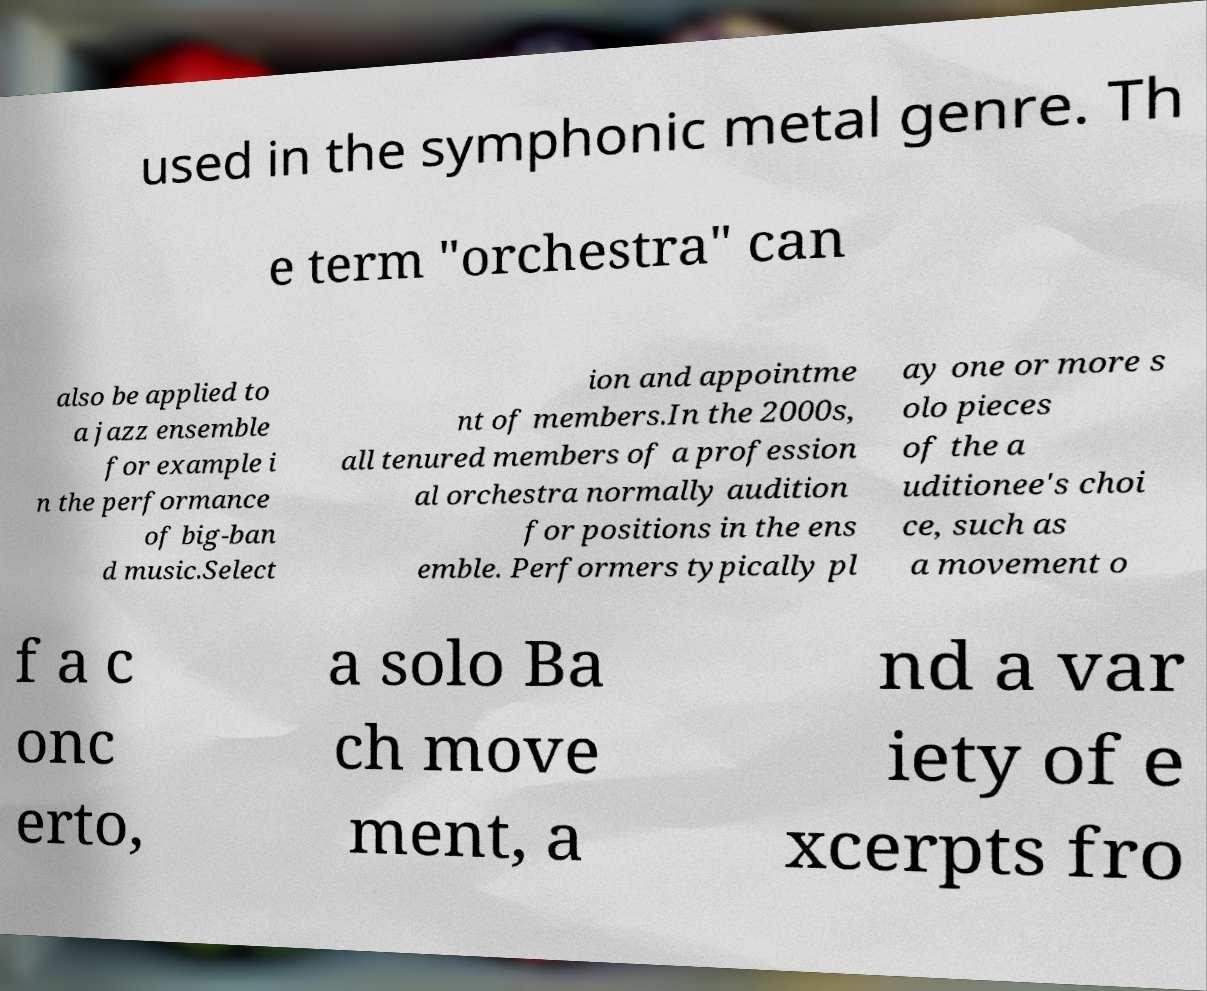Can you accurately transcribe the text from the provided image for me? used in the symphonic metal genre. Th e term "orchestra" can also be applied to a jazz ensemble for example i n the performance of big-ban d music.Select ion and appointme nt of members.In the 2000s, all tenured members of a profession al orchestra normally audition for positions in the ens emble. Performers typically pl ay one or more s olo pieces of the a uditionee's choi ce, such as a movement o f a c onc erto, a solo Ba ch move ment, a nd a var iety of e xcerpts fro 